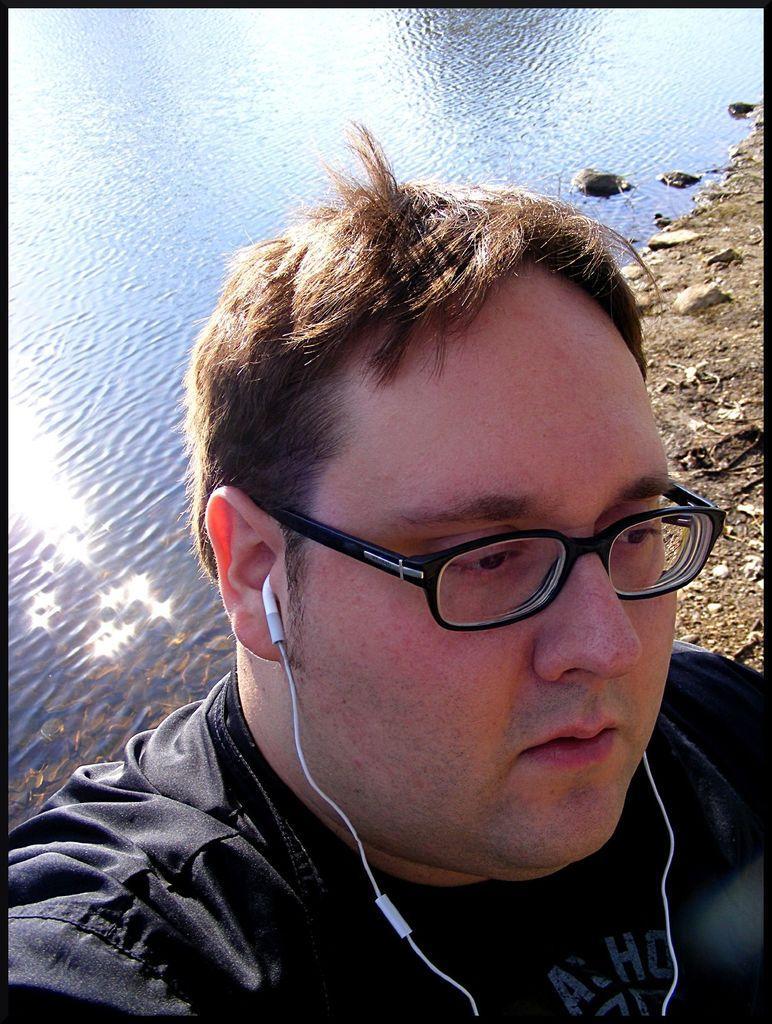Can you describe this image briefly? In this image, I can see a man with spectacles and earphones. Behind the man, there is water. On the right side of the image, I can see the rocks on the ground. 